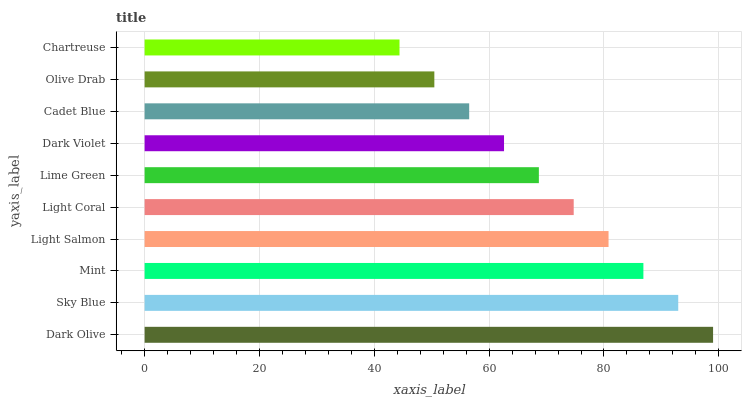Is Chartreuse the minimum?
Answer yes or no. Yes. Is Dark Olive the maximum?
Answer yes or no. Yes. Is Sky Blue the minimum?
Answer yes or no. No. Is Sky Blue the maximum?
Answer yes or no. No. Is Dark Olive greater than Sky Blue?
Answer yes or no. Yes. Is Sky Blue less than Dark Olive?
Answer yes or no. Yes. Is Sky Blue greater than Dark Olive?
Answer yes or no. No. Is Dark Olive less than Sky Blue?
Answer yes or no. No. Is Light Coral the high median?
Answer yes or no. Yes. Is Lime Green the low median?
Answer yes or no. Yes. Is Olive Drab the high median?
Answer yes or no. No. Is Dark Olive the low median?
Answer yes or no. No. 